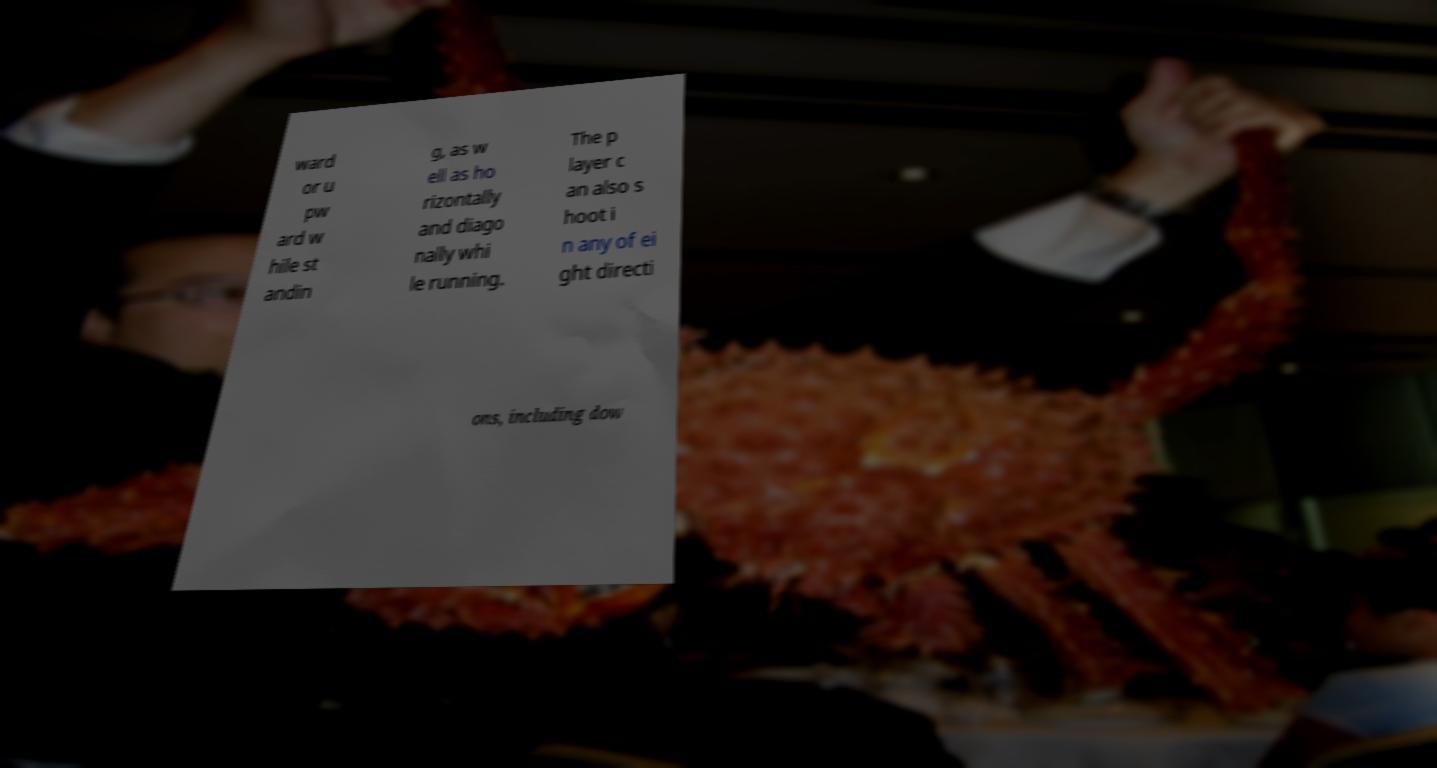For documentation purposes, I need the text within this image transcribed. Could you provide that? ward or u pw ard w hile st andin g, as w ell as ho rizontally and diago nally whi le running. The p layer c an also s hoot i n any of ei ght directi ons, including dow 